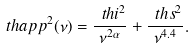<formula> <loc_0><loc_0><loc_500><loc_500>\ t h a p p ^ { 2 } ( \nu ) = \frac { \ t h i ^ { 2 } } { \nu ^ { 2 \alpha } } + \frac { \ t h s ^ { 2 } } { \nu ^ { 4 . 4 } } .</formula> 